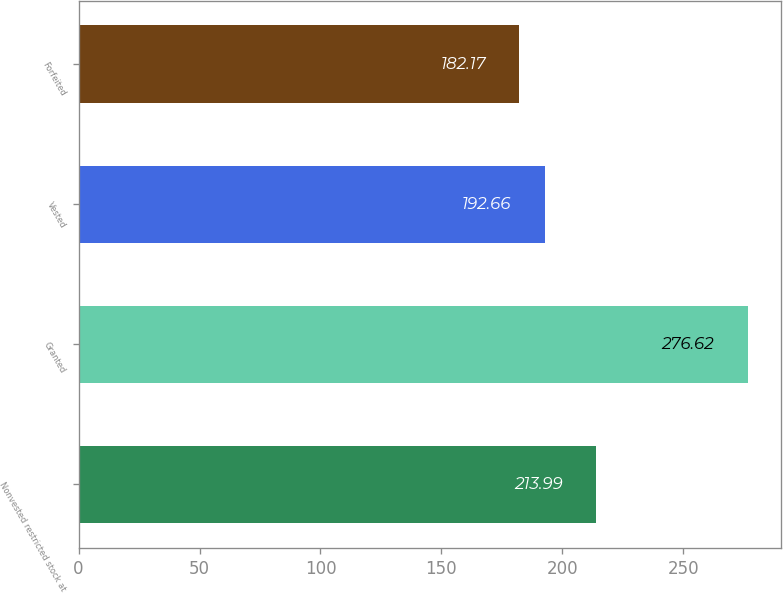Convert chart to OTSL. <chart><loc_0><loc_0><loc_500><loc_500><bar_chart><fcel>Nonvested restricted stock at<fcel>Granted<fcel>Vested<fcel>Forfeited<nl><fcel>213.99<fcel>276.62<fcel>192.66<fcel>182.17<nl></chart> 